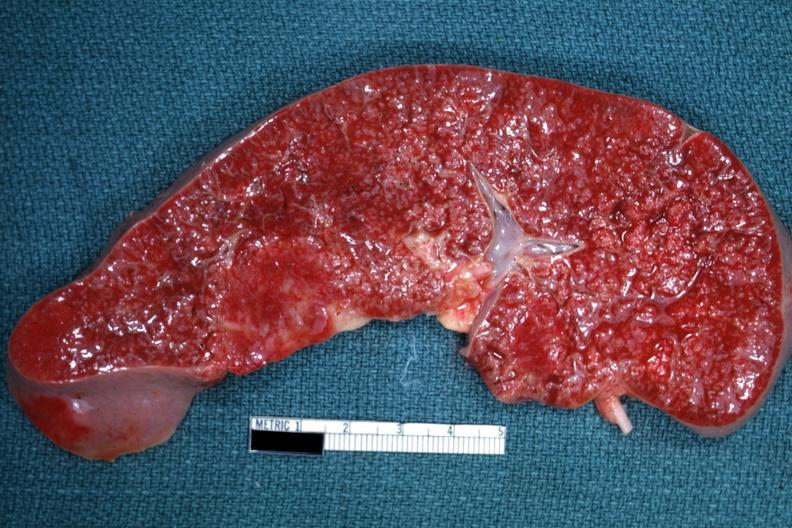does this image show cut surface with multiple small infiltrates that simulate granulomata diagnosed as reticulum cell sarcoma?
Answer the question using a single word or phrase. Yes 